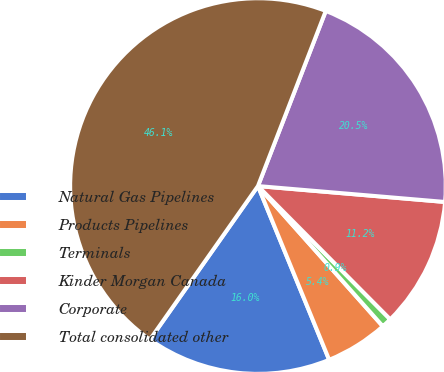Convert chart. <chart><loc_0><loc_0><loc_500><loc_500><pie_chart><fcel>Natural Gas Pipelines<fcel>Products Pipelines<fcel>Terminals<fcel>Kinder Morgan Canada<fcel>Corporate<fcel>Total consolidated other<nl><fcel>15.95%<fcel>5.39%<fcel>0.86%<fcel>11.21%<fcel>20.47%<fcel>46.12%<nl></chart> 